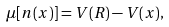<formula> <loc_0><loc_0><loc_500><loc_500>\mu [ n ( x ) ] = V ( R ) - V ( x ) ,</formula> 